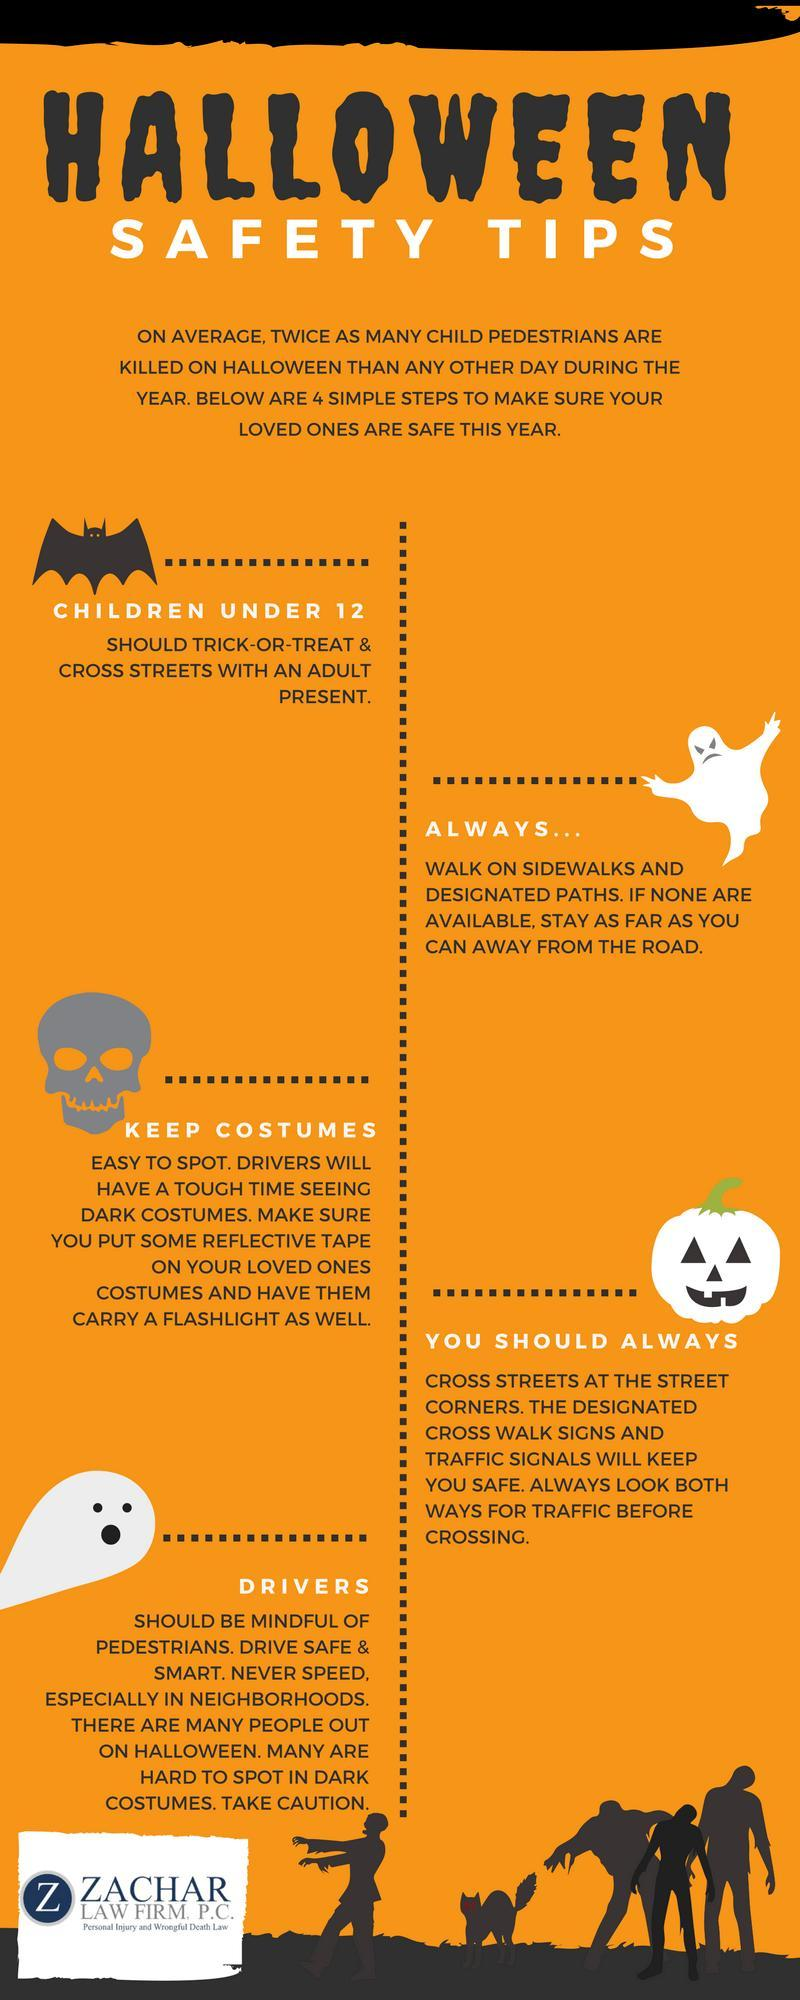What can be used to make costumes visible
Answer the question with a short phrase. reflective tape Who need to look out for pedestrians drivers What is a traditional Halloween custom trick-or-treat 